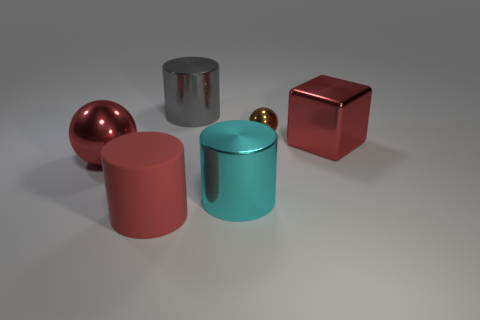Subtract all gray cylinders. How many cylinders are left? 2 Add 1 cyan cylinders. How many objects exist? 7 Subtract all cyan cylinders. How many cylinders are left? 2 Subtract 3 cylinders. How many cylinders are left? 0 Subtract all spheres. How many objects are left? 4 Subtract all red balls. Subtract all green cylinders. How many balls are left? 1 Subtract all green spheres. How many red cylinders are left? 1 Subtract all brown metal things. Subtract all cyan metal things. How many objects are left? 4 Add 4 red matte cylinders. How many red matte cylinders are left? 5 Add 4 small red shiny cubes. How many small red shiny cubes exist? 4 